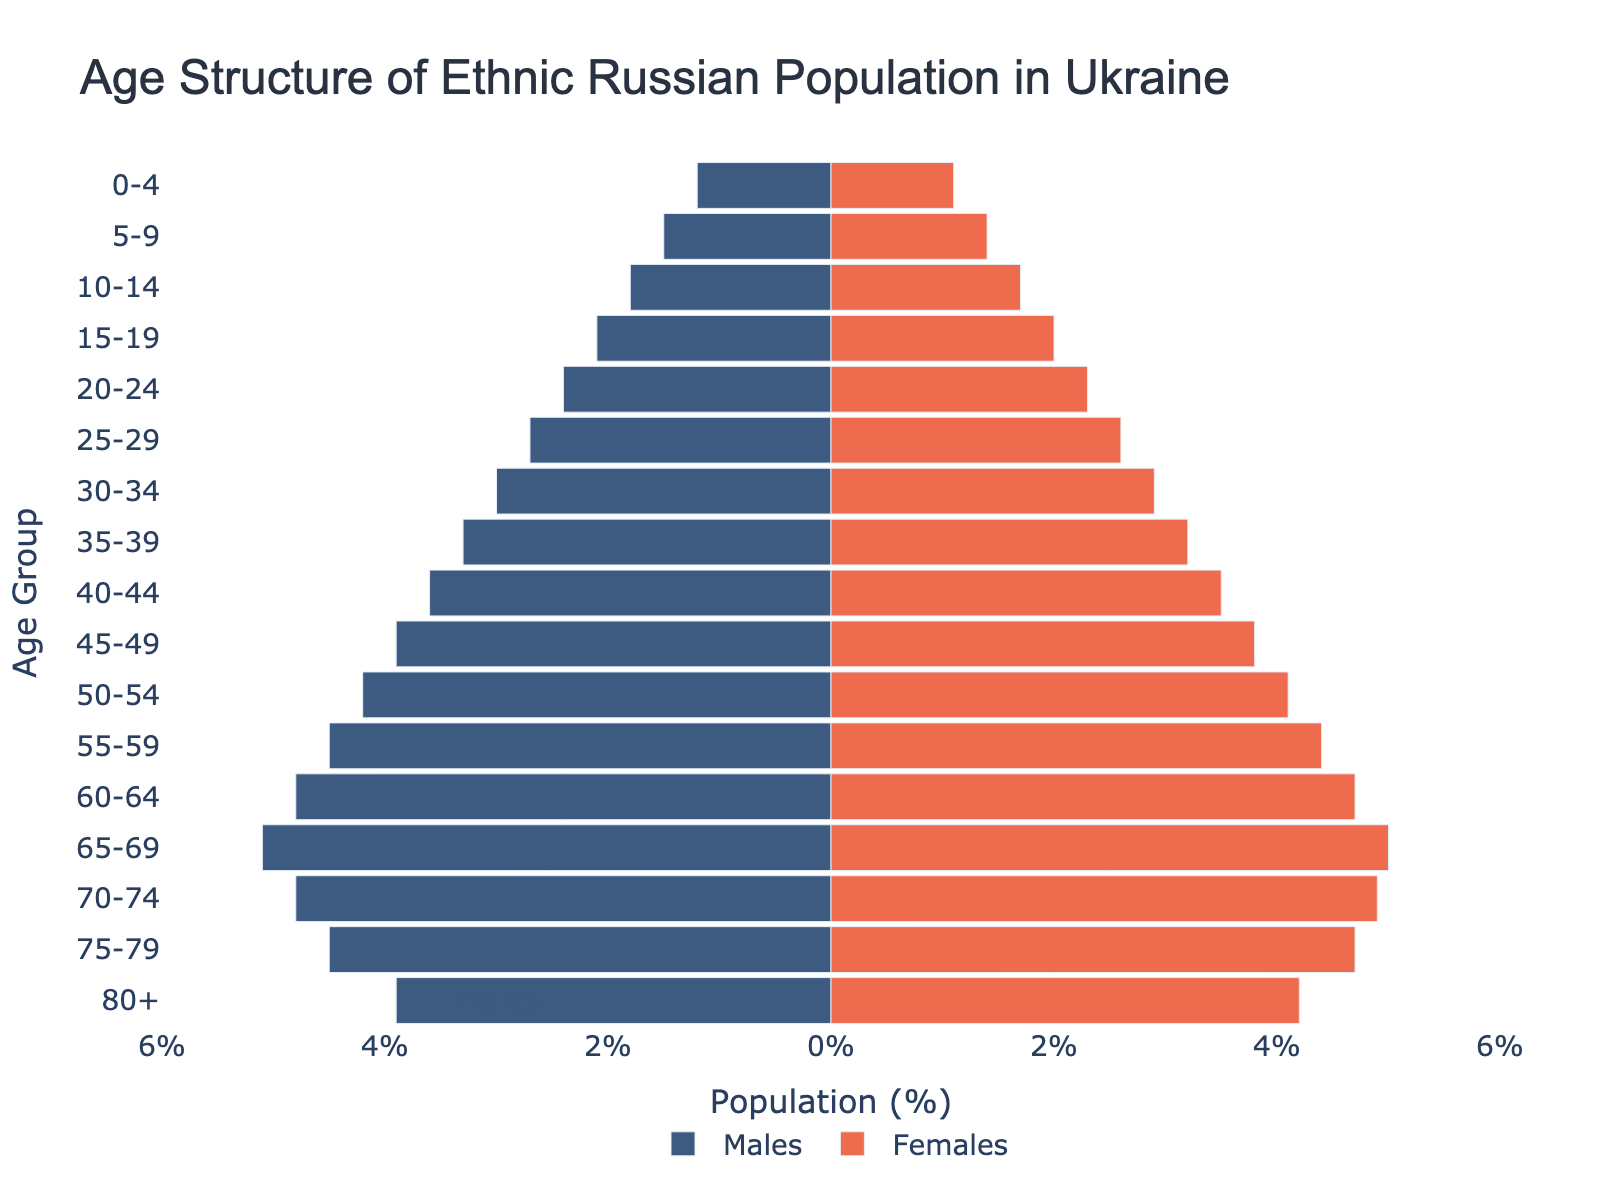What is the title of the figure? The title text is placed at the top of the figure. By reading it, we can identify that the title of the figure is "Age Structure of Ethnic Russian Population in Ukraine".
Answer: Age Structure of Ethnic Russian Population in Ukraine What do the colors blue and red represent in the pyramid? By examining the legend often found at the bottom or side of the figure, we can determine that blue represents Males and red represents Females.
Answer: Males and Females Which age group has the largest population percentage for both males and females? By looking at the bars' length in both the blue and red sections, the 65-69 age group stands out as having the longest bars for both males and females, indicating that this group has the largest population percentage.
Answer: 65-69 What is the population percentage of females in the 80+ age group? The position of the red bar associated with the 80+ age group can be read from the horizontal axis values. The bar extends to 4.2%.
Answer: 4.2% Do males or females have a larger population percentage in the 30-34 age group? Comparing the length of the blue and red bars for the 30-34 age group, the blue bar (males) extends further than the red bar (females), indicating a larger population percentage for males.
Answer: Males What is the combined population percentage of males and females in the 50-54 age group? To find the total, we add the percentages for males and females: 4.2% for males and 4.1% for females, resulting in 8.3%.
Answer: 8.3% Which gender has a higher population in the oldest age group (80+)? We compare the lengths of the blue and red bars for the 80+ age group, where the red bar extends further, indicating that females have a higher population percentage.
Answer: Females How has the population percentage trend changed from the 0-4 age group to the 25-29 age group for males? By examining the blue bars from the 0-4 to the 25-29 age groups, there is a noticeable increasing trend in the population percentage, starting from 1.2% and reaching 2.7%.
Answer: Increasing What is the difference in population percentage between males and females in the 70-74 age group? The population percentage for males is 4.8%, and for females, it is 4.9%. Subtracting these values gives a difference of 0.1%.
Answer: 0.1% Which age group shows the most balanced population percentage between males and females, and what is this percentage? By comparing the lengths of the bars for each age group, the 60-64 age group has nearly identical bar lengths, both at 4.7%.
Answer: 60-64, 4.7% 